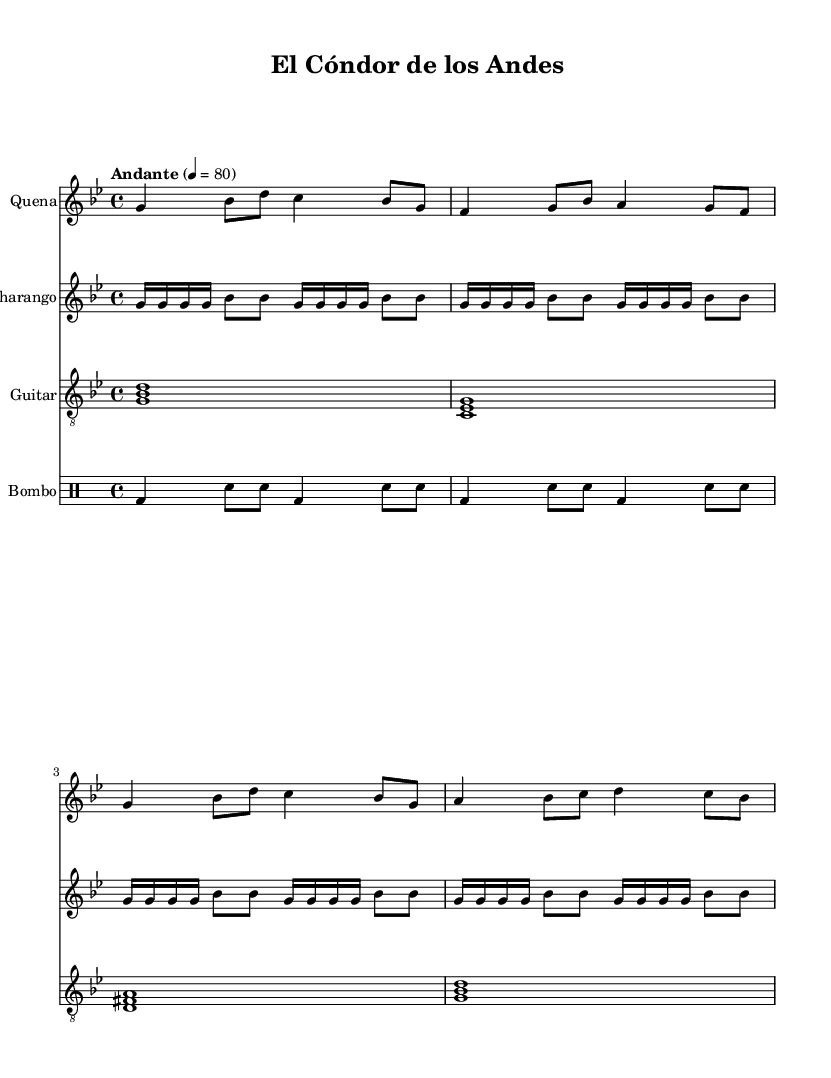What is the key signature of this music? The key signature is G minor, which has two flats (B flat and E flat). This can be identified by looking at the key signature at the beginning of the staff.
Answer: G minor What is the time signature of this piece? The time signature is 4/4, which is indicated at the beginning of the score. It means there are four beats in each measure and the quarter note gets one beat.
Answer: 4/4 What is the tempo marking for this piece? The tempo marking is "Andante," which indicates a moderate tempo. This can be seen in the tempo directive written above the staff.
Answer: Andante How many notes are in the first measure of the Quena part? The first measure of the Quena part contains five notes (G, B flat, D, C, and B flat). Counting the distinct notes in that measure confirms this total.
Answer: Five Which instruments are included in this piece? The instruments included are Quena, Charango, Guitar, and Bombo. This information can be found in the staff labels at the beginning of each instrument's part.
Answer: Quena, Charango, Guitar, Bombo What rhythmic pattern does the Bombo play? The Bombo plays a repeating pattern of bass drum and snare hits. This can be seen in the drumming notation which repeats two times.
Answer: Bass and snare What cultural influences are reflected in this music? The cultural influences reflected in this music are indigenous and Spanish. This can be inferred from the style of the musical instruments and the melodies commonly associated with Andean folk music.
Answer: Indigenous and Spanish 